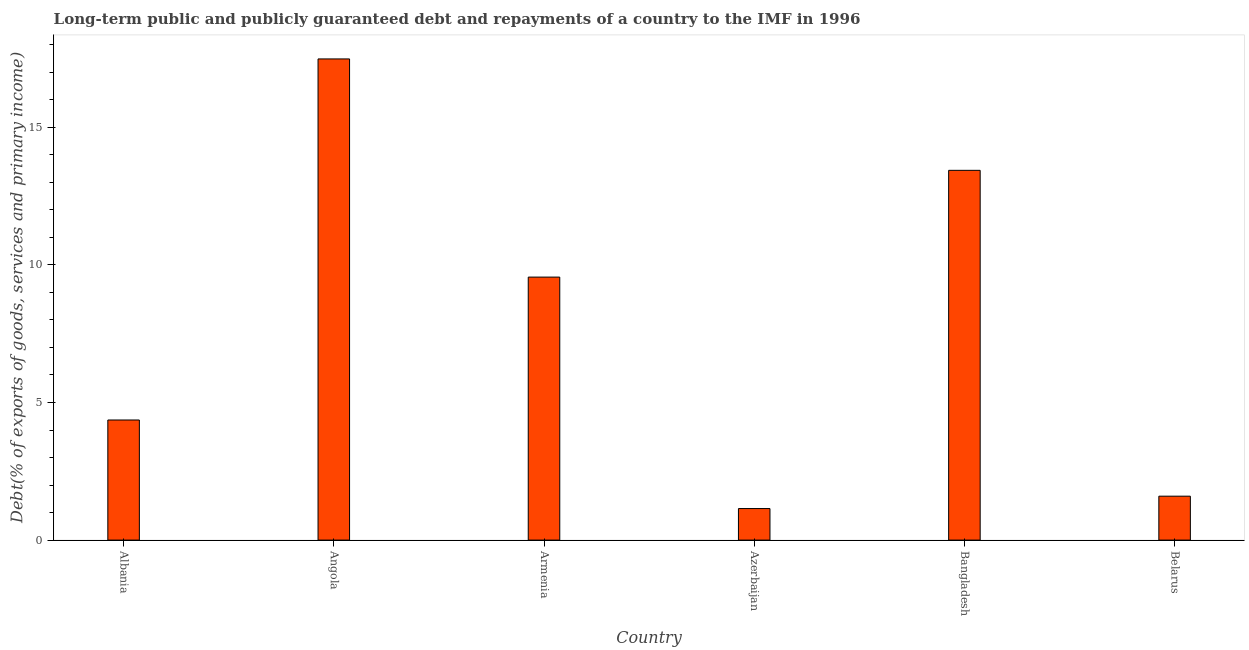What is the title of the graph?
Your answer should be very brief. Long-term public and publicly guaranteed debt and repayments of a country to the IMF in 1996. What is the label or title of the X-axis?
Your response must be concise. Country. What is the label or title of the Y-axis?
Make the answer very short. Debt(% of exports of goods, services and primary income). What is the debt service in Angola?
Make the answer very short. 17.48. Across all countries, what is the maximum debt service?
Your response must be concise. 17.48. Across all countries, what is the minimum debt service?
Offer a terse response. 1.15. In which country was the debt service maximum?
Offer a terse response. Angola. In which country was the debt service minimum?
Your answer should be compact. Azerbaijan. What is the sum of the debt service?
Offer a very short reply. 47.58. What is the difference between the debt service in Albania and Armenia?
Provide a succinct answer. -5.19. What is the average debt service per country?
Offer a very short reply. 7.93. What is the median debt service?
Provide a short and direct response. 6.96. Is the debt service in Angola less than that in Armenia?
Offer a very short reply. No. Is the difference between the debt service in Bangladesh and Belarus greater than the difference between any two countries?
Give a very brief answer. No. What is the difference between the highest and the second highest debt service?
Keep it short and to the point. 4.05. What is the difference between the highest and the lowest debt service?
Provide a succinct answer. 16.34. How many bars are there?
Your response must be concise. 6. What is the Debt(% of exports of goods, services and primary income) of Albania?
Offer a very short reply. 4.36. What is the Debt(% of exports of goods, services and primary income) in Angola?
Your answer should be very brief. 17.48. What is the Debt(% of exports of goods, services and primary income) of Armenia?
Make the answer very short. 9.56. What is the Debt(% of exports of goods, services and primary income) of Azerbaijan?
Offer a very short reply. 1.15. What is the Debt(% of exports of goods, services and primary income) in Bangladesh?
Provide a short and direct response. 13.44. What is the Debt(% of exports of goods, services and primary income) of Belarus?
Provide a succinct answer. 1.6. What is the difference between the Debt(% of exports of goods, services and primary income) in Albania and Angola?
Provide a succinct answer. -13.12. What is the difference between the Debt(% of exports of goods, services and primary income) in Albania and Armenia?
Your response must be concise. -5.19. What is the difference between the Debt(% of exports of goods, services and primary income) in Albania and Azerbaijan?
Your response must be concise. 3.22. What is the difference between the Debt(% of exports of goods, services and primary income) in Albania and Bangladesh?
Your answer should be very brief. -9.07. What is the difference between the Debt(% of exports of goods, services and primary income) in Albania and Belarus?
Provide a short and direct response. 2.77. What is the difference between the Debt(% of exports of goods, services and primary income) in Angola and Armenia?
Your response must be concise. 7.93. What is the difference between the Debt(% of exports of goods, services and primary income) in Angola and Azerbaijan?
Provide a succinct answer. 16.34. What is the difference between the Debt(% of exports of goods, services and primary income) in Angola and Bangladesh?
Ensure brevity in your answer.  4.05. What is the difference between the Debt(% of exports of goods, services and primary income) in Angola and Belarus?
Your answer should be very brief. 15.89. What is the difference between the Debt(% of exports of goods, services and primary income) in Armenia and Azerbaijan?
Offer a very short reply. 8.41. What is the difference between the Debt(% of exports of goods, services and primary income) in Armenia and Bangladesh?
Give a very brief answer. -3.88. What is the difference between the Debt(% of exports of goods, services and primary income) in Armenia and Belarus?
Your answer should be compact. 7.96. What is the difference between the Debt(% of exports of goods, services and primary income) in Azerbaijan and Bangladesh?
Make the answer very short. -12.29. What is the difference between the Debt(% of exports of goods, services and primary income) in Azerbaijan and Belarus?
Your answer should be very brief. -0.45. What is the difference between the Debt(% of exports of goods, services and primary income) in Bangladesh and Belarus?
Offer a very short reply. 11.84. What is the ratio of the Debt(% of exports of goods, services and primary income) in Albania to that in Armenia?
Your response must be concise. 0.46. What is the ratio of the Debt(% of exports of goods, services and primary income) in Albania to that in Azerbaijan?
Offer a very short reply. 3.81. What is the ratio of the Debt(% of exports of goods, services and primary income) in Albania to that in Bangladesh?
Make the answer very short. 0.33. What is the ratio of the Debt(% of exports of goods, services and primary income) in Albania to that in Belarus?
Provide a short and direct response. 2.73. What is the ratio of the Debt(% of exports of goods, services and primary income) in Angola to that in Armenia?
Provide a succinct answer. 1.83. What is the ratio of the Debt(% of exports of goods, services and primary income) in Angola to that in Azerbaijan?
Your answer should be compact. 15.26. What is the ratio of the Debt(% of exports of goods, services and primary income) in Angola to that in Bangladesh?
Offer a terse response. 1.3. What is the ratio of the Debt(% of exports of goods, services and primary income) in Angola to that in Belarus?
Provide a succinct answer. 10.96. What is the ratio of the Debt(% of exports of goods, services and primary income) in Armenia to that in Azerbaijan?
Your response must be concise. 8.34. What is the ratio of the Debt(% of exports of goods, services and primary income) in Armenia to that in Bangladesh?
Offer a terse response. 0.71. What is the ratio of the Debt(% of exports of goods, services and primary income) in Armenia to that in Belarus?
Offer a very short reply. 5.99. What is the ratio of the Debt(% of exports of goods, services and primary income) in Azerbaijan to that in Bangladesh?
Offer a terse response. 0.09. What is the ratio of the Debt(% of exports of goods, services and primary income) in Azerbaijan to that in Belarus?
Ensure brevity in your answer.  0.72. What is the ratio of the Debt(% of exports of goods, services and primary income) in Bangladesh to that in Belarus?
Ensure brevity in your answer.  8.42. 